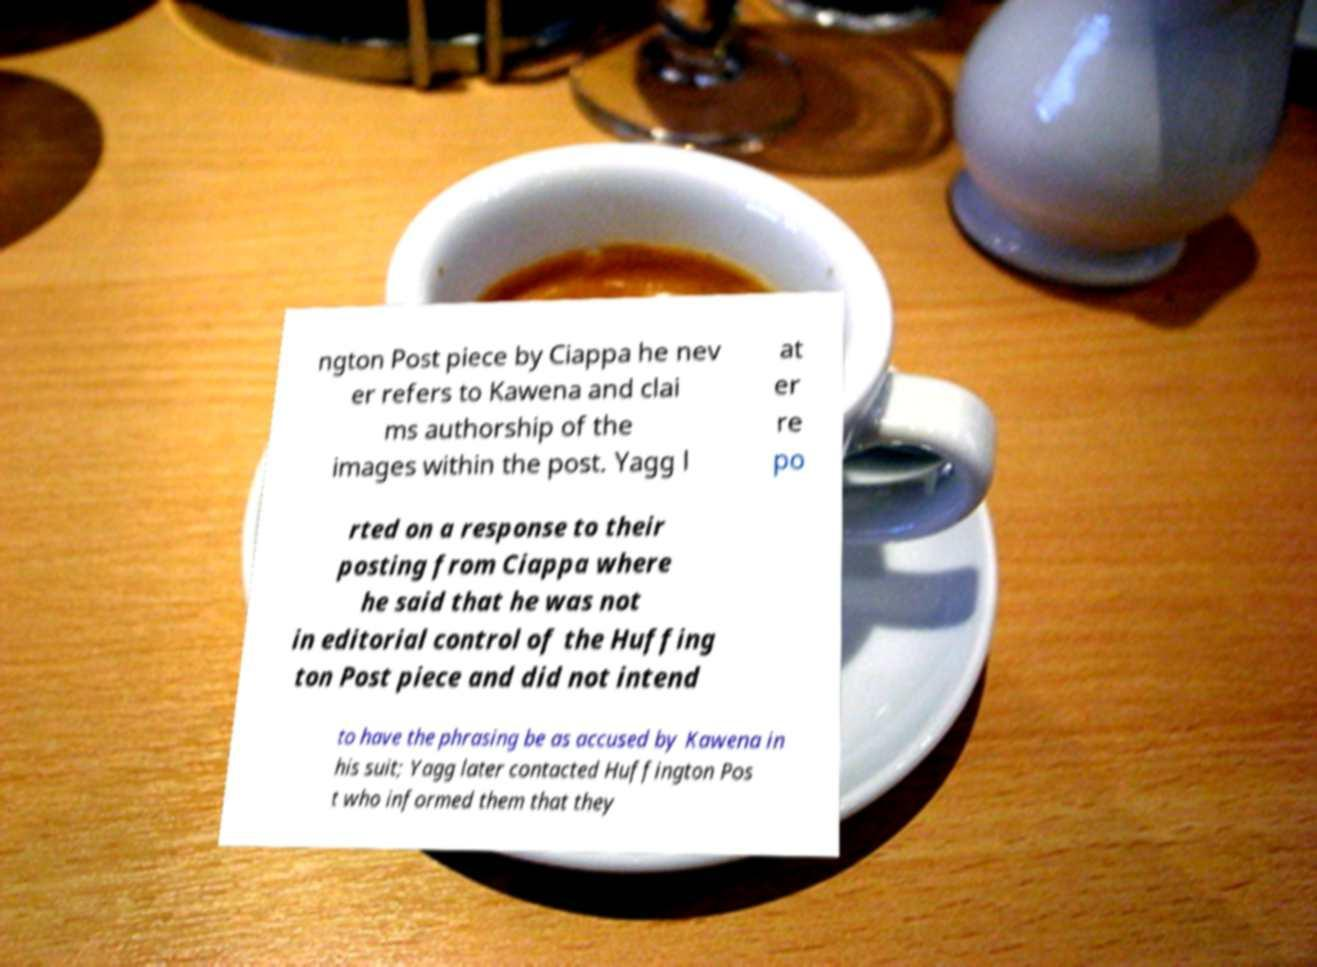Can you accurately transcribe the text from the provided image for me? ngton Post piece by Ciappa he nev er refers to Kawena and clai ms authorship of the images within the post. Yagg l at er re po rted on a response to their posting from Ciappa where he said that he was not in editorial control of the Huffing ton Post piece and did not intend to have the phrasing be as accused by Kawena in his suit; Yagg later contacted Huffington Pos t who informed them that they 